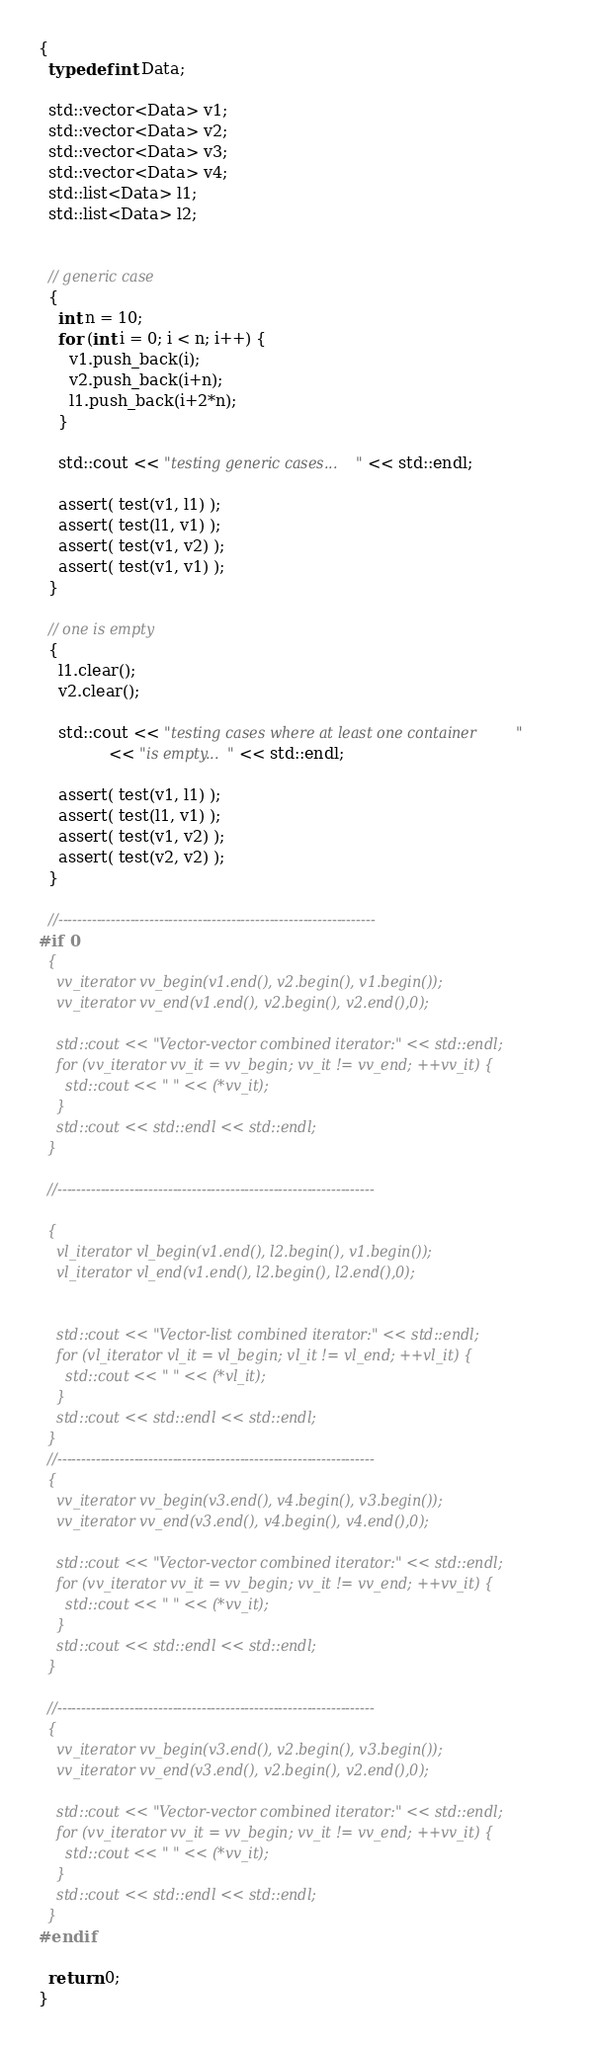<code> <loc_0><loc_0><loc_500><loc_500><_C++_>{
  typedef int Data;

  std::vector<Data> v1;
  std::vector<Data> v2;
  std::vector<Data> v3;
  std::vector<Data> v4;
  std::list<Data> l1;
  std::list<Data> l2;


  // generic case
  {
    int n = 10;
    for (int i = 0; i < n; i++) {
      v1.push_back(i);
      v2.push_back(i+n);
      l1.push_back(i+2*n);
    }

    std::cout << "testing generic cases..." << std::endl;

    assert( test(v1, l1) );
    assert( test(l1, v1) );
    assert( test(v1, v2) );
    assert( test(v1, v1) );
  }

  // one is empty
  {
    l1.clear();
    v2.clear();

    std::cout << "testing cases where at least one container "
              << "is empty..." << std::endl;

    assert( test(v1, l1) );
    assert( test(l1, v1) );
    assert( test(v1, v2) );
    assert( test(v2, v2) );
  }

  //------------------------------------------------------------------
#if 0
  {
    vv_iterator vv_begin(v1.end(), v2.begin(), v1.begin());
    vv_iterator vv_end(v1.end(), v2.begin(), v2.end(),0);

    std::cout << "Vector-vector combined iterator:" << std::endl;
    for (vv_iterator vv_it = vv_begin; vv_it != vv_end; ++vv_it) {
      std::cout << " " << (*vv_it);
    }
    std::cout << std::endl << std::endl;
  }

  //------------------------------------------------------------------

  {
    vl_iterator vl_begin(v1.end(), l2.begin(), v1.begin());
    vl_iterator vl_end(v1.end(), l2.begin(), l2.end(),0);


    std::cout << "Vector-list combined iterator:" << std::endl;
    for (vl_iterator vl_it = vl_begin; vl_it != vl_end; ++vl_it) {
      std::cout << " " << (*vl_it);
    }
    std::cout << std::endl << std::endl;
  }
  //------------------------------------------------------------------
  {
    vv_iterator vv_begin(v3.end(), v4.begin(), v3.begin());
    vv_iterator vv_end(v3.end(), v4.begin(), v4.end(),0);

    std::cout << "Vector-vector combined iterator:" << std::endl;
    for (vv_iterator vv_it = vv_begin; vv_it != vv_end; ++vv_it) {
      std::cout << " " << (*vv_it);
    }
    std::cout << std::endl << std::endl;
  }

  //------------------------------------------------------------------
  {
    vv_iterator vv_begin(v3.end(), v2.begin(), v3.begin());
    vv_iterator vv_end(v3.end(), v2.begin(), v2.end(),0);

    std::cout << "Vector-vector combined iterator:" << std::endl;
    for (vv_iterator vv_it = vv_begin; vv_it != vv_end; ++vv_it) {
      std::cout << " " << (*vv_it);
    }
    std::cout << std::endl << std::endl;
  }
#endif

  return 0;
}

</code> 